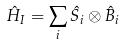Convert formula to latex. <formula><loc_0><loc_0><loc_500><loc_500>\hat { H } _ { I } = \sum _ { i } \hat { S _ { i } } \otimes \hat { B } _ { i }</formula> 